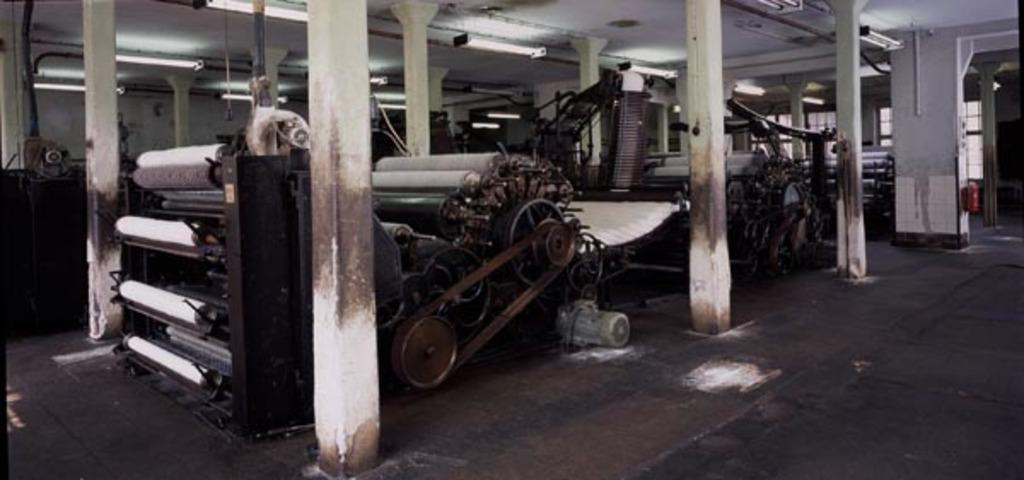What is the main object in the image? There is a machine in the image. What architectural features can be seen in the image? There are pillars and a roof visible in the image. What type of illumination is present in the image? There are lights in the image. What surface is the machine and other objects resting on? There is a floor in the image. What color stands out in the image? There is a red color object in the image. Can you see the sail on the machine in the image? There is no sail present on the machine in the image. What type of curve can be seen on the roof in the image? The roof in the image does not have any visible curves. 